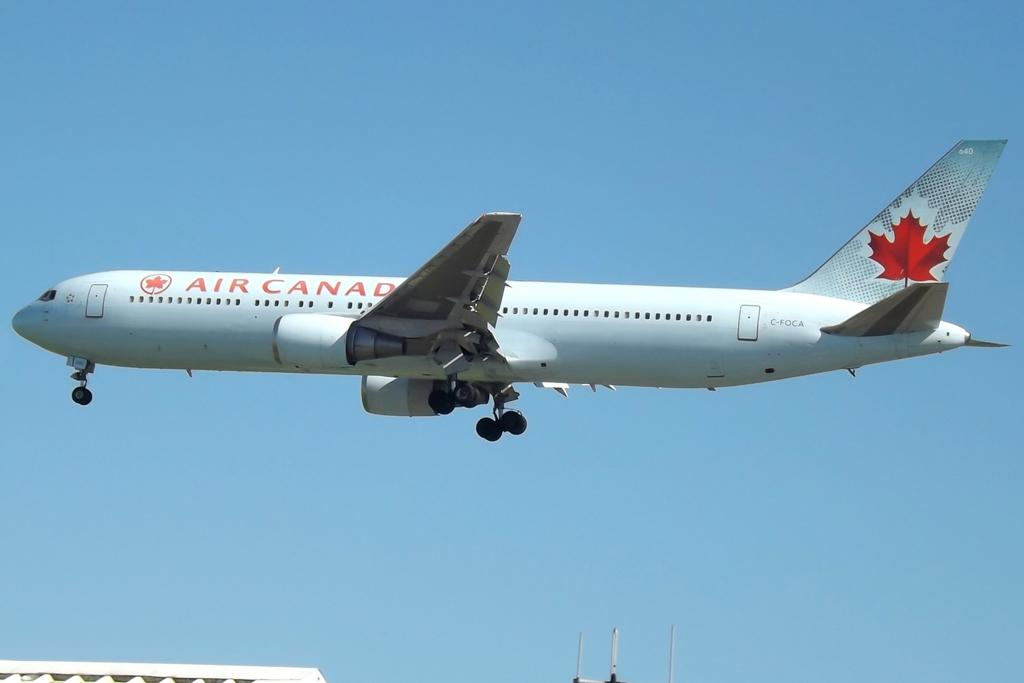<image>
Write a terse but informative summary of the picture. An  Air Canada written on the side with a maple leaf. 